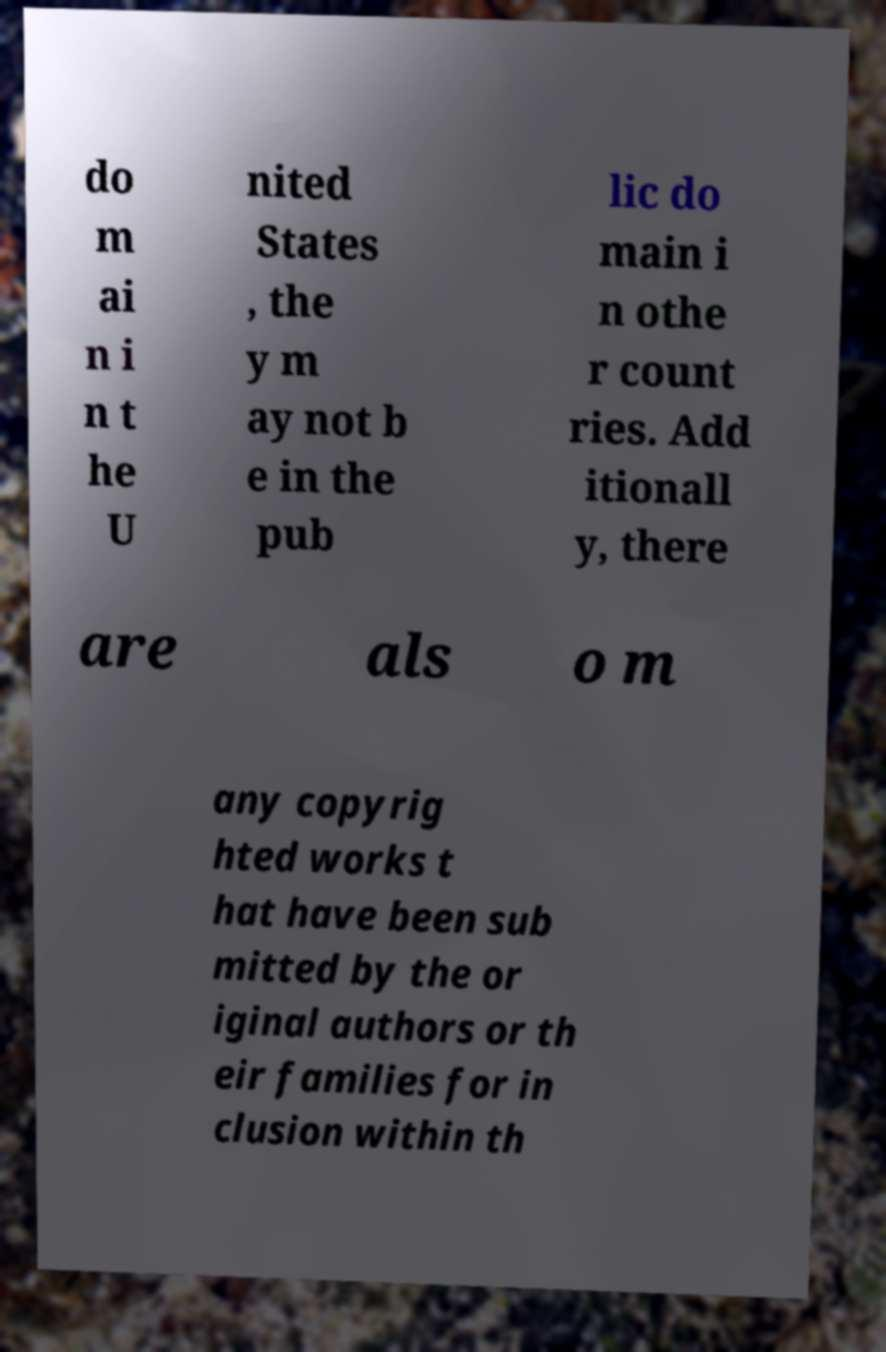There's text embedded in this image that I need extracted. Can you transcribe it verbatim? do m ai n i n t he U nited States , the y m ay not b e in the pub lic do main i n othe r count ries. Add itionall y, there are als o m any copyrig hted works t hat have been sub mitted by the or iginal authors or th eir families for in clusion within th 